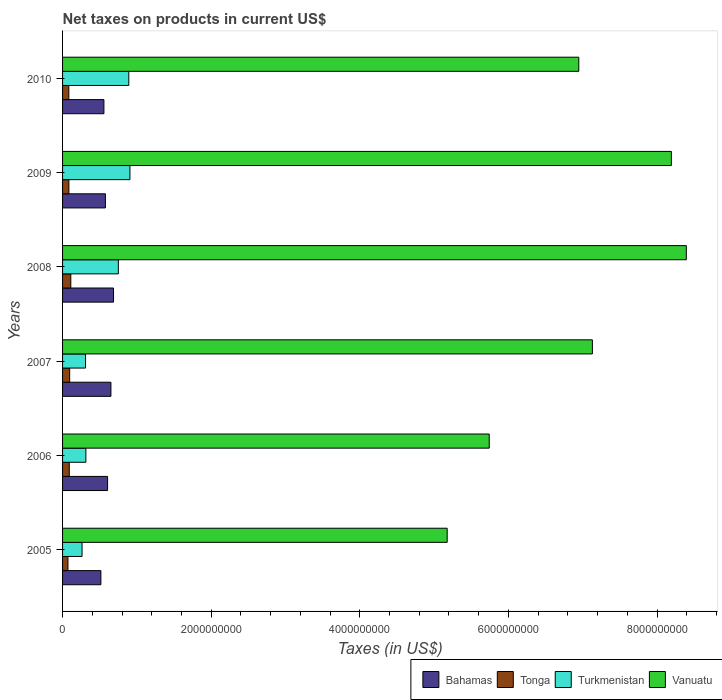How many groups of bars are there?
Offer a terse response. 6. Are the number of bars per tick equal to the number of legend labels?
Provide a short and direct response. Yes. How many bars are there on the 3rd tick from the top?
Give a very brief answer. 4. How many bars are there on the 4th tick from the bottom?
Make the answer very short. 4. What is the label of the 6th group of bars from the top?
Offer a very short reply. 2005. In how many cases, is the number of bars for a given year not equal to the number of legend labels?
Offer a terse response. 0. What is the net taxes on products in Bahamas in 2010?
Ensure brevity in your answer.  5.57e+08. Across all years, what is the maximum net taxes on products in Tonga?
Provide a succinct answer. 1.11e+08. Across all years, what is the minimum net taxes on products in Turkmenistan?
Keep it short and to the point. 2.62e+08. In which year was the net taxes on products in Turkmenistan maximum?
Provide a short and direct response. 2009. In which year was the net taxes on products in Bahamas minimum?
Provide a short and direct response. 2005. What is the total net taxes on products in Bahamas in the graph?
Provide a succinct answer. 3.59e+09. What is the difference between the net taxes on products in Bahamas in 2006 and that in 2008?
Offer a terse response. -7.99e+07. What is the difference between the net taxes on products in Vanuatu in 2010 and the net taxes on products in Bahamas in 2005?
Provide a succinct answer. 6.43e+09. What is the average net taxes on products in Vanuatu per year?
Give a very brief answer. 6.93e+09. In the year 2010, what is the difference between the net taxes on products in Tonga and net taxes on products in Bahamas?
Keep it short and to the point. -4.72e+08. In how many years, is the net taxes on products in Tonga greater than 800000000 US$?
Provide a succinct answer. 0. What is the ratio of the net taxes on products in Bahamas in 2005 to that in 2007?
Your answer should be compact. 0.79. Is the net taxes on products in Vanuatu in 2006 less than that in 2008?
Keep it short and to the point. Yes. Is the difference between the net taxes on products in Tonga in 2007 and 2009 greater than the difference between the net taxes on products in Bahamas in 2007 and 2009?
Keep it short and to the point. No. What is the difference between the highest and the second highest net taxes on products in Vanuatu?
Your answer should be compact. 2.01e+08. What is the difference between the highest and the lowest net taxes on products in Vanuatu?
Make the answer very short. 3.22e+09. Is it the case that in every year, the sum of the net taxes on products in Bahamas and net taxes on products in Turkmenistan is greater than the sum of net taxes on products in Tonga and net taxes on products in Vanuatu?
Your answer should be very brief. No. What does the 1st bar from the top in 2006 represents?
Ensure brevity in your answer.  Vanuatu. What does the 1st bar from the bottom in 2006 represents?
Give a very brief answer. Bahamas. Is it the case that in every year, the sum of the net taxes on products in Bahamas and net taxes on products in Turkmenistan is greater than the net taxes on products in Vanuatu?
Provide a succinct answer. No. How many bars are there?
Provide a succinct answer. 24. How many years are there in the graph?
Give a very brief answer. 6. What is the difference between two consecutive major ticks on the X-axis?
Provide a succinct answer. 2.00e+09. Are the values on the major ticks of X-axis written in scientific E-notation?
Ensure brevity in your answer.  No. Does the graph contain any zero values?
Make the answer very short. No. What is the title of the graph?
Make the answer very short. Net taxes on products in current US$. What is the label or title of the X-axis?
Ensure brevity in your answer.  Taxes (in US$). What is the Taxes (in US$) in Bahamas in 2005?
Give a very brief answer. 5.16e+08. What is the Taxes (in US$) of Tonga in 2005?
Your response must be concise. 7.23e+07. What is the Taxes (in US$) of Turkmenistan in 2005?
Give a very brief answer. 2.62e+08. What is the Taxes (in US$) in Vanuatu in 2005?
Your answer should be very brief. 5.18e+09. What is the Taxes (in US$) in Bahamas in 2006?
Keep it short and to the point. 6.06e+08. What is the Taxes (in US$) in Tonga in 2006?
Give a very brief answer. 9.02e+07. What is the Taxes (in US$) of Turkmenistan in 2006?
Keep it short and to the point. 3.14e+08. What is the Taxes (in US$) of Vanuatu in 2006?
Provide a succinct answer. 5.74e+09. What is the Taxes (in US$) in Bahamas in 2007?
Ensure brevity in your answer.  6.51e+08. What is the Taxes (in US$) in Tonga in 2007?
Make the answer very short. 9.57e+07. What is the Taxes (in US$) in Turkmenistan in 2007?
Your answer should be compact. 3.09e+08. What is the Taxes (in US$) of Vanuatu in 2007?
Offer a terse response. 7.13e+09. What is the Taxes (in US$) in Bahamas in 2008?
Your response must be concise. 6.86e+08. What is the Taxes (in US$) in Tonga in 2008?
Keep it short and to the point. 1.11e+08. What is the Taxes (in US$) in Turkmenistan in 2008?
Give a very brief answer. 7.51e+08. What is the Taxes (in US$) of Vanuatu in 2008?
Give a very brief answer. 8.39e+09. What is the Taxes (in US$) of Bahamas in 2009?
Keep it short and to the point. 5.76e+08. What is the Taxes (in US$) in Tonga in 2009?
Give a very brief answer. 8.51e+07. What is the Taxes (in US$) of Turkmenistan in 2009?
Offer a terse response. 9.07e+08. What is the Taxes (in US$) in Vanuatu in 2009?
Make the answer very short. 8.19e+09. What is the Taxes (in US$) in Bahamas in 2010?
Provide a succinct answer. 5.57e+08. What is the Taxes (in US$) in Tonga in 2010?
Give a very brief answer. 8.43e+07. What is the Taxes (in US$) in Turkmenistan in 2010?
Ensure brevity in your answer.  8.91e+08. What is the Taxes (in US$) in Vanuatu in 2010?
Give a very brief answer. 6.95e+09. Across all years, what is the maximum Taxes (in US$) in Bahamas?
Provide a succinct answer. 6.86e+08. Across all years, what is the maximum Taxes (in US$) of Tonga?
Keep it short and to the point. 1.11e+08. Across all years, what is the maximum Taxes (in US$) in Turkmenistan?
Provide a short and direct response. 9.07e+08. Across all years, what is the maximum Taxes (in US$) in Vanuatu?
Provide a succinct answer. 8.39e+09. Across all years, what is the minimum Taxes (in US$) of Bahamas?
Your answer should be compact. 5.16e+08. Across all years, what is the minimum Taxes (in US$) of Tonga?
Ensure brevity in your answer.  7.23e+07. Across all years, what is the minimum Taxes (in US$) in Turkmenistan?
Your answer should be very brief. 2.62e+08. Across all years, what is the minimum Taxes (in US$) of Vanuatu?
Give a very brief answer. 5.18e+09. What is the total Taxes (in US$) in Bahamas in the graph?
Offer a very short reply. 3.59e+09. What is the total Taxes (in US$) of Tonga in the graph?
Your answer should be very brief. 5.38e+08. What is the total Taxes (in US$) of Turkmenistan in the graph?
Provide a succinct answer. 3.43e+09. What is the total Taxes (in US$) of Vanuatu in the graph?
Your answer should be very brief. 4.16e+1. What is the difference between the Taxes (in US$) of Bahamas in 2005 and that in 2006?
Offer a terse response. -9.00e+07. What is the difference between the Taxes (in US$) of Tonga in 2005 and that in 2006?
Your answer should be very brief. -1.78e+07. What is the difference between the Taxes (in US$) in Turkmenistan in 2005 and that in 2006?
Offer a terse response. -5.12e+07. What is the difference between the Taxes (in US$) of Vanuatu in 2005 and that in 2006?
Provide a short and direct response. -5.66e+08. What is the difference between the Taxes (in US$) in Bahamas in 2005 and that in 2007?
Make the answer very short. -1.35e+08. What is the difference between the Taxes (in US$) in Tonga in 2005 and that in 2007?
Your answer should be very brief. -2.33e+07. What is the difference between the Taxes (in US$) of Turkmenistan in 2005 and that in 2007?
Give a very brief answer. -4.68e+07. What is the difference between the Taxes (in US$) of Vanuatu in 2005 and that in 2007?
Your answer should be very brief. -1.95e+09. What is the difference between the Taxes (in US$) in Bahamas in 2005 and that in 2008?
Keep it short and to the point. -1.70e+08. What is the difference between the Taxes (in US$) in Tonga in 2005 and that in 2008?
Your response must be concise. -3.85e+07. What is the difference between the Taxes (in US$) in Turkmenistan in 2005 and that in 2008?
Make the answer very short. -4.88e+08. What is the difference between the Taxes (in US$) in Vanuatu in 2005 and that in 2008?
Offer a very short reply. -3.22e+09. What is the difference between the Taxes (in US$) of Bahamas in 2005 and that in 2009?
Offer a very short reply. -6.07e+07. What is the difference between the Taxes (in US$) of Tonga in 2005 and that in 2009?
Provide a short and direct response. -1.27e+07. What is the difference between the Taxes (in US$) in Turkmenistan in 2005 and that in 2009?
Keep it short and to the point. -6.44e+08. What is the difference between the Taxes (in US$) of Vanuatu in 2005 and that in 2009?
Your answer should be very brief. -3.02e+09. What is the difference between the Taxes (in US$) in Bahamas in 2005 and that in 2010?
Give a very brief answer. -4.07e+07. What is the difference between the Taxes (in US$) in Tonga in 2005 and that in 2010?
Your response must be concise. -1.20e+07. What is the difference between the Taxes (in US$) of Turkmenistan in 2005 and that in 2010?
Offer a terse response. -6.29e+08. What is the difference between the Taxes (in US$) of Vanuatu in 2005 and that in 2010?
Ensure brevity in your answer.  -1.77e+09. What is the difference between the Taxes (in US$) of Bahamas in 2006 and that in 2007?
Provide a succinct answer. -4.49e+07. What is the difference between the Taxes (in US$) of Tonga in 2006 and that in 2007?
Offer a very short reply. -5.49e+06. What is the difference between the Taxes (in US$) of Turkmenistan in 2006 and that in 2007?
Your response must be concise. 4.40e+06. What is the difference between the Taxes (in US$) in Vanuatu in 2006 and that in 2007?
Your response must be concise. -1.39e+09. What is the difference between the Taxes (in US$) in Bahamas in 2006 and that in 2008?
Your answer should be compact. -7.99e+07. What is the difference between the Taxes (in US$) of Tonga in 2006 and that in 2008?
Offer a very short reply. -2.07e+07. What is the difference between the Taxes (in US$) of Turkmenistan in 2006 and that in 2008?
Provide a succinct answer. -4.37e+08. What is the difference between the Taxes (in US$) of Vanuatu in 2006 and that in 2008?
Offer a terse response. -2.65e+09. What is the difference between the Taxes (in US$) of Bahamas in 2006 and that in 2009?
Give a very brief answer. 2.93e+07. What is the difference between the Taxes (in US$) of Tonga in 2006 and that in 2009?
Offer a very short reply. 5.11e+06. What is the difference between the Taxes (in US$) in Turkmenistan in 2006 and that in 2009?
Offer a terse response. -5.93e+08. What is the difference between the Taxes (in US$) in Vanuatu in 2006 and that in 2009?
Your answer should be very brief. -2.45e+09. What is the difference between the Taxes (in US$) in Bahamas in 2006 and that in 2010?
Your response must be concise. 4.92e+07. What is the difference between the Taxes (in US$) in Tonga in 2006 and that in 2010?
Provide a short and direct response. 5.81e+06. What is the difference between the Taxes (in US$) in Turkmenistan in 2006 and that in 2010?
Keep it short and to the point. -5.78e+08. What is the difference between the Taxes (in US$) in Vanuatu in 2006 and that in 2010?
Make the answer very short. -1.20e+09. What is the difference between the Taxes (in US$) of Bahamas in 2007 and that in 2008?
Give a very brief answer. -3.50e+07. What is the difference between the Taxes (in US$) in Tonga in 2007 and that in 2008?
Keep it short and to the point. -1.52e+07. What is the difference between the Taxes (in US$) in Turkmenistan in 2007 and that in 2008?
Provide a succinct answer. -4.41e+08. What is the difference between the Taxes (in US$) in Vanuatu in 2007 and that in 2008?
Offer a terse response. -1.26e+09. What is the difference between the Taxes (in US$) in Bahamas in 2007 and that in 2009?
Ensure brevity in your answer.  7.42e+07. What is the difference between the Taxes (in US$) of Tonga in 2007 and that in 2009?
Offer a very short reply. 1.06e+07. What is the difference between the Taxes (in US$) of Turkmenistan in 2007 and that in 2009?
Make the answer very short. -5.98e+08. What is the difference between the Taxes (in US$) in Vanuatu in 2007 and that in 2009?
Offer a terse response. -1.06e+09. What is the difference between the Taxes (in US$) of Bahamas in 2007 and that in 2010?
Offer a terse response. 9.41e+07. What is the difference between the Taxes (in US$) of Tonga in 2007 and that in 2010?
Offer a terse response. 1.13e+07. What is the difference between the Taxes (in US$) in Turkmenistan in 2007 and that in 2010?
Your answer should be very brief. -5.82e+08. What is the difference between the Taxes (in US$) in Vanuatu in 2007 and that in 2010?
Make the answer very short. 1.83e+08. What is the difference between the Taxes (in US$) in Bahamas in 2008 and that in 2009?
Provide a short and direct response. 1.09e+08. What is the difference between the Taxes (in US$) in Tonga in 2008 and that in 2009?
Offer a terse response. 2.58e+07. What is the difference between the Taxes (in US$) of Turkmenistan in 2008 and that in 2009?
Ensure brevity in your answer.  -1.56e+08. What is the difference between the Taxes (in US$) of Vanuatu in 2008 and that in 2009?
Your answer should be very brief. 2.01e+08. What is the difference between the Taxes (in US$) of Bahamas in 2008 and that in 2010?
Keep it short and to the point. 1.29e+08. What is the difference between the Taxes (in US$) in Tonga in 2008 and that in 2010?
Keep it short and to the point. 2.65e+07. What is the difference between the Taxes (in US$) of Turkmenistan in 2008 and that in 2010?
Provide a short and direct response. -1.41e+08. What is the difference between the Taxes (in US$) in Vanuatu in 2008 and that in 2010?
Offer a terse response. 1.45e+09. What is the difference between the Taxes (in US$) of Bahamas in 2009 and that in 2010?
Your answer should be very brief. 1.99e+07. What is the difference between the Taxes (in US$) in Tonga in 2009 and that in 2010?
Provide a succinct answer. 7.02e+05. What is the difference between the Taxes (in US$) of Turkmenistan in 2009 and that in 2010?
Your answer should be compact. 1.54e+07. What is the difference between the Taxes (in US$) of Vanuatu in 2009 and that in 2010?
Offer a very short reply. 1.25e+09. What is the difference between the Taxes (in US$) in Bahamas in 2005 and the Taxes (in US$) in Tonga in 2006?
Provide a succinct answer. 4.26e+08. What is the difference between the Taxes (in US$) in Bahamas in 2005 and the Taxes (in US$) in Turkmenistan in 2006?
Provide a short and direct response. 2.02e+08. What is the difference between the Taxes (in US$) of Bahamas in 2005 and the Taxes (in US$) of Vanuatu in 2006?
Offer a very short reply. -5.23e+09. What is the difference between the Taxes (in US$) in Tonga in 2005 and the Taxes (in US$) in Turkmenistan in 2006?
Make the answer very short. -2.41e+08. What is the difference between the Taxes (in US$) of Tonga in 2005 and the Taxes (in US$) of Vanuatu in 2006?
Provide a short and direct response. -5.67e+09. What is the difference between the Taxes (in US$) of Turkmenistan in 2005 and the Taxes (in US$) of Vanuatu in 2006?
Ensure brevity in your answer.  -5.48e+09. What is the difference between the Taxes (in US$) of Bahamas in 2005 and the Taxes (in US$) of Tonga in 2007?
Offer a very short reply. 4.20e+08. What is the difference between the Taxes (in US$) of Bahamas in 2005 and the Taxes (in US$) of Turkmenistan in 2007?
Give a very brief answer. 2.07e+08. What is the difference between the Taxes (in US$) in Bahamas in 2005 and the Taxes (in US$) in Vanuatu in 2007?
Your answer should be compact. -6.61e+09. What is the difference between the Taxes (in US$) of Tonga in 2005 and the Taxes (in US$) of Turkmenistan in 2007?
Provide a succinct answer. -2.37e+08. What is the difference between the Taxes (in US$) in Tonga in 2005 and the Taxes (in US$) in Vanuatu in 2007?
Give a very brief answer. -7.06e+09. What is the difference between the Taxes (in US$) in Turkmenistan in 2005 and the Taxes (in US$) in Vanuatu in 2007?
Your response must be concise. -6.87e+09. What is the difference between the Taxes (in US$) in Bahamas in 2005 and the Taxes (in US$) in Tonga in 2008?
Provide a short and direct response. 4.05e+08. What is the difference between the Taxes (in US$) in Bahamas in 2005 and the Taxes (in US$) in Turkmenistan in 2008?
Your answer should be very brief. -2.35e+08. What is the difference between the Taxes (in US$) in Bahamas in 2005 and the Taxes (in US$) in Vanuatu in 2008?
Offer a terse response. -7.88e+09. What is the difference between the Taxes (in US$) of Tonga in 2005 and the Taxes (in US$) of Turkmenistan in 2008?
Keep it short and to the point. -6.78e+08. What is the difference between the Taxes (in US$) in Tonga in 2005 and the Taxes (in US$) in Vanuatu in 2008?
Your answer should be compact. -8.32e+09. What is the difference between the Taxes (in US$) in Turkmenistan in 2005 and the Taxes (in US$) in Vanuatu in 2008?
Your response must be concise. -8.13e+09. What is the difference between the Taxes (in US$) of Bahamas in 2005 and the Taxes (in US$) of Tonga in 2009?
Your answer should be very brief. 4.31e+08. What is the difference between the Taxes (in US$) in Bahamas in 2005 and the Taxes (in US$) in Turkmenistan in 2009?
Your answer should be compact. -3.91e+08. What is the difference between the Taxes (in US$) in Bahamas in 2005 and the Taxes (in US$) in Vanuatu in 2009?
Make the answer very short. -7.68e+09. What is the difference between the Taxes (in US$) of Tonga in 2005 and the Taxes (in US$) of Turkmenistan in 2009?
Your answer should be very brief. -8.34e+08. What is the difference between the Taxes (in US$) in Tonga in 2005 and the Taxes (in US$) in Vanuatu in 2009?
Offer a very short reply. -8.12e+09. What is the difference between the Taxes (in US$) in Turkmenistan in 2005 and the Taxes (in US$) in Vanuatu in 2009?
Give a very brief answer. -7.93e+09. What is the difference between the Taxes (in US$) in Bahamas in 2005 and the Taxes (in US$) in Tonga in 2010?
Offer a very short reply. 4.31e+08. What is the difference between the Taxes (in US$) in Bahamas in 2005 and the Taxes (in US$) in Turkmenistan in 2010?
Your answer should be compact. -3.75e+08. What is the difference between the Taxes (in US$) of Bahamas in 2005 and the Taxes (in US$) of Vanuatu in 2010?
Give a very brief answer. -6.43e+09. What is the difference between the Taxes (in US$) in Tonga in 2005 and the Taxes (in US$) in Turkmenistan in 2010?
Offer a very short reply. -8.19e+08. What is the difference between the Taxes (in US$) in Tonga in 2005 and the Taxes (in US$) in Vanuatu in 2010?
Make the answer very short. -6.87e+09. What is the difference between the Taxes (in US$) of Turkmenistan in 2005 and the Taxes (in US$) of Vanuatu in 2010?
Your answer should be very brief. -6.68e+09. What is the difference between the Taxes (in US$) in Bahamas in 2006 and the Taxes (in US$) in Tonga in 2007?
Offer a terse response. 5.10e+08. What is the difference between the Taxes (in US$) in Bahamas in 2006 and the Taxes (in US$) in Turkmenistan in 2007?
Offer a terse response. 2.97e+08. What is the difference between the Taxes (in US$) of Bahamas in 2006 and the Taxes (in US$) of Vanuatu in 2007?
Keep it short and to the point. -6.52e+09. What is the difference between the Taxes (in US$) of Tonga in 2006 and the Taxes (in US$) of Turkmenistan in 2007?
Your answer should be very brief. -2.19e+08. What is the difference between the Taxes (in US$) in Tonga in 2006 and the Taxes (in US$) in Vanuatu in 2007?
Your answer should be very brief. -7.04e+09. What is the difference between the Taxes (in US$) in Turkmenistan in 2006 and the Taxes (in US$) in Vanuatu in 2007?
Your answer should be compact. -6.82e+09. What is the difference between the Taxes (in US$) of Bahamas in 2006 and the Taxes (in US$) of Tonga in 2008?
Provide a succinct answer. 4.95e+08. What is the difference between the Taxes (in US$) in Bahamas in 2006 and the Taxes (in US$) in Turkmenistan in 2008?
Give a very brief answer. -1.45e+08. What is the difference between the Taxes (in US$) in Bahamas in 2006 and the Taxes (in US$) in Vanuatu in 2008?
Provide a short and direct response. -7.79e+09. What is the difference between the Taxes (in US$) of Tonga in 2006 and the Taxes (in US$) of Turkmenistan in 2008?
Keep it short and to the point. -6.60e+08. What is the difference between the Taxes (in US$) of Tonga in 2006 and the Taxes (in US$) of Vanuatu in 2008?
Offer a terse response. -8.30e+09. What is the difference between the Taxes (in US$) in Turkmenistan in 2006 and the Taxes (in US$) in Vanuatu in 2008?
Keep it short and to the point. -8.08e+09. What is the difference between the Taxes (in US$) of Bahamas in 2006 and the Taxes (in US$) of Tonga in 2009?
Keep it short and to the point. 5.21e+08. What is the difference between the Taxes (in US$) of Bahamas in 2006 and the Taxes (in US$) of Turkmenistan in 2009?
Offer a very short reply. -3.01e+08. What is the difference between the Taxes (in US$) of Bahamas in 2006 and the Taxes (in US$) of Vanuatu in 2009?
Ensure brevity in your answer.  -7.59e+09. What is the difference between the Taxes (in US$) in Tonga in 2006 and the Taxes (in US$) in Turkmenistan in 2009?
Your answer should be compact. -8.17e+08. What is the difference between the Taxes (in US$) in Tonga in 2006 and the Taxes (in US$) in Vanuatu in 2009?
Your answer should be very brief. -8.10e+09. What is the difference between the Taxes (in US$) of Turkmenistan in 2006 and the Taxes (in US$) of Vanuatu in 2009?
Ensure brevity in your answer.  -7.88e+09. What is the difference between the Taxes (in US$) of Bahamas in 2006 and the Taxes (in US$) of Tonga in 2010?
Your answer should be compact. 5.21e+08. What is the difference between the Taxes (in US$) of Bahamas in 2006 and the Taxes (in US$) of Turkmenistan in 2010?
Your response must be concise. -2.85e+08. What is the difference between the Taxes (in US$) in Bahamas in 2006 and the Taxes (in US$) in Vanuatu in 2010?
Keep it short and to the point. -6.34e+09. What is the difference between the Taxes (in US$) in Tonga in 2006 and the Taxes (in US$) in Turkmenistan in 2010?
Keep it short and to the point. -8.01e+08. What is the difference between the Taxes (in US$) in Tonga in 2006 and the Taxes (in US$) in Vanuatu in 2010?
Provide a succinct answer. -6.86e+09. What is the difference between the Taxes (in US$) of Turkmenistan in 2006 and the Taxes (in US$) of Vanuatu in 2010?
Ensure brevity in your answer.  -6.63e+09. What is the difference between the Taxes (in US$) of Bahamas in 2007 and the Taxes (in US$) of Tonga in 2008?
Make the answer very short. 5.40e+08. What is the difference between the Taxes (in US$) in Bahamas in 2007 and the Taxes (in US$) in Turkmenistan in 2008?
Keep it short and to the point. -1.00e+08. What is the difference between the Taxes (in US$) of Bahamas in 2007 and the Taxes (in US$) of Vanuatu in 2008?
Keep it short and to the point. -7.74e+09. What is the difference between the Taxes (in US$) in Tonga in 2007 and the Taxes (in US$) in Turkmenistan in 2008?
Offer a very short reply. -6.55e+08. What is the difference between the Taxes (in US$) in Tonga in 2007 and the Taxes (in US$) in Vanuatu in 2008?
Provide a succinct answer. -8.30e+09. What is the difference between the Taxes (in US$) in Turkmenistan in 2007 and the Taxes (in US$) in Vanuatu in 2008?
Ensure brevity in your answer.  -8.08e+09. What is the difference between the Taxes (in US$) of Bahamas in 2007 and the Taxes (in US$) of Tonga in 2009?
Provide a succinct answer. 5.66e+08. What is the difference between the Taxes (in US$) in Bahamas in 2007 and the Taxes (in US$) in Turkmenistan in 2009?
Your response must be concise. -2.56e+08. What is the difference between the Taxes (in US$) of Bahamas in 2007 and the Taxes (in US$) of Vanuatu in 2009?
Your answer should be compact. -7.54e+09. What is the difference between the Taxes (in US$) of Tonga in 2007 and the Taxes (in US$) of Turkmenistan in 2009?
Your response must be concise. -8.11e+08. What is the difference between the Taxes (in US$) in Tonga in 2007 and the Taxes (in US$) in Vanuatu in 2009?
Make the answer very short. -8.10e+09. What is the difference between the Taxes (in US$) in Turkmenistan in 2007 and the Taxes (in US$) in Vanuatu in 2009?
Provide a succinct answer. -7.88e+09. What is the difference between the Taxes (in US$) in Bahamas in 2007 and the Taxes (in US$) in Tonga in 2010?
Keep it short and to the point. 5.66e+08. What is the difference between the Taxes (in US$) of Bahamas in 2007 and the Taxes (in US$) of Turkmenistan in 2010?
Offer a terse response. -2.41e+08. What is the difference between the Taxes (in US$) of Bahamas in 2007 and the Taxes (in US$) of Vanuatu in 2010?
Keep it short and to the point. -6.30e+09. What is the difference between the Taxes (in US$) of Tonga in 2007 and the Taxes (in US$) of Turkmenistan in 2010?
Offer a very short reply. -7.96e+08. What is the difference between the Taxes (in US$) in Tonga in 2007 and the Taxes (in US$) in Vanuatu in 2010?
Keep it short and to the point. -6.85e+09. What is the difference between the Taxes (in US$) of Turkmenistan in 2007 and the Taxes (in US$) of Vanuatu in 2010?
Provide a short and direct response. -6.64e+09. What is the difference between the Taxes (in US$) in Bahamas in 2008 and the Taxes (in US$) in Tonga in 2009?
Make the answer very short. 6.01e+08. What is the difference between the Taxes (in US$) of Bahamas in 2008 and the Taxes (in US$) of Turkmenistan in 2009?
Ensure brevity in your answer.  -2.21e+08. What is the difference between the Taxes (in US$) in Bahamas in 2008 and the Taxes (in US$) in Vanuatu in 2009?
Make the answer very short. -7.51e+09. What is the difference between the Taxes (in US$) of Tonga in 2008 and the Taxes (in US$) of Turkmenistan in 2009?
Offer a terse response. -7.96e+08. What is the difference between the Taxes (in US$) in Tonga in 2008 and the Taxes (in US$) in Vanuatu in 2009?
Offer a very short reply. -8.08e+09. What is the difference between the Taxes (in US$) of Turkmenistan in 2008 and the Taxes (in US$) of Vanuatu in 2009?
Keep it short and to the point. -7.44e+09. What is the difference between the Taxes (in US$) in Bahamas in 2008 and the Taxes (in US$) in Tonga in 2010?
Provide a short and direct response. 6.01e+08. What is the difference between the Taxes (in US$) in Bahamas in 2008 and the Taxes (in US$) in Turkmenistan in 2010?
Your answer should be very brief. -2.06e+08. What is the difference between the Taxes (in US$) in Bahamas in 2008 and the Taxes (in US$) in Vanuatu in 2010?
Ensure brevity in your answer.  -6.26e+09. What is the difference between the Taxes (in US$) of Tonga in 2008 and the Taxes (in US$) of Turkmenistan in 2010?
Your answer should be very brief. -7.80e+08. What is the difference between the Taxes (in US$) of Tonga in 2008 and the Taxes (in US$) of Vanuatu in 2010?
Provide a short and direct response. -6.84e+09. What is the difference between the Taxes (in US$) in Turkmenistan in 2008 and the Taxes (in US$) in Vanuatu in 2010?
Give a very brief answer. -6.20e+09. What is the difference between the Taxes (in US$) of Bahamas in 2009 and the Taxes (in US$) of Tonga in 2010?
Offer a terse response. 4.92e+08. What is the difference between the Taxes (in US$) of Bahamas in 2009 and the Taxes (in US$) of Turkmenistan in 2010?
Offer a very short reply. -3.15e+08. What is the difference between the Taxes (in US$) in Bahamas in 2009 and the Taxes (in US$) in Vanuatu in 2010?
Keep it short and to the point. -6.37e+09. What is the difference between the Taxes (in US$) of Tonga in 2009 and the Taxes (in US$) of Turkmenistan in 2010?
Make the answer very short. -8.06e+08. What is the difference between the Taxes (in US$) of Tonga in 2009 and the Taxes (in US$) of Vanuatu in 2010?
Offer a terse response. -6.86e+09. What is the difference between the Taxes (in US$) of Turkmenistan in 2009 and the Taxes (in US$) of Vanuatu in 2010?
Your answer should be compact. -6.04e+09. What is the average Taxes (in US$) in Bahamas per year?
Ensure brevity in your answer.  5.98e+08. What is the average Taxes (in US$) in Tonga per year?
Your response must be concise. 8.97e+07. What is the average Taxes (in US$) of Turkmenistan per year?
Make the answer very short. 5.72e+08. What is the average Taxes (in US$) of Vanuatu per year?
Ensure brevity in your answer.  6.93e+09. In the year 2005, what is the difference between the Taxes (in US$) of Bahamas and Taxes (in US$) of Tonga?
Your response must be concise. 4.43e+08. In the year 2005, what is the difference between the Taxes (in US$) of Bahamas and Taxes (in US$) of Turkmenistan?
Your response must be concise. 2.53e+08. In the year 2005, what is the difference between the Taxes (in US$) in Bahamas and Taxes (in US$) in Vanuatu?
Offer a terse response. -4.66e+09. In the year 2005, what is the difference between the Taxes (in US$) in Tonga and Taxes (in US$) in Turkmenistan?
Your response must be concise. -1.90e+08. In the year 2005, what is the difference between the Taxes (in US$) of Tonga and Taxes (in US$) of Vanuatu?
Your answer should be very brief. -5.10e+09. In the year 2005, what is the difference between the Taxes (in US$) in Turkmenistan and Taxes (in US$) in Vanuatu?
Your answer should be very brief. -4.91e+09. In the year 2006, what is the difference between the Taxes (in US$) of Bahamas and Taxes (in US$) of Tonga?
Offer a very short reply. 5.16e+08. In the year 2006, what is the difference between the Taxes (in US$) in Bahamas and Taxes (in US$) in Turkmenistan?
Provide a succinct answer. 2.92e+08. In the year 2006, what is the difference between the Taxes (in US$) of Bahamas and Taxes (in US$) of Vanuatu?
Provide a succinct answer. -5.14e+09. In the year 2006, what is the difference between the Taxes (in US$) of Tonga and Taxes (in US$) of Turkmenistan?
Provide a short and direct response. -2.23e+08. In the year 2006, what is the difference between the Taxes (in US$) of Tonga and Taxes (in US$) of Vanuatu?
Offer a very short reply. -5.65e+09. In the year 2006, what is the difference between the Taxes (in US$) of Turkmenistan and Taxes (in US$) of Vanuatu?
Provide a succinct answer. -5.43e+09. In the year 2007, what is the difference between the Taxes (in US$) of Bahamas and Taxes (in US$) of Tonga?
Offer a very short reply. 5.55e+08. In the year 2007, what is the difference between the Taxes (in US$) of Bahamas and Taxes (in US$) of Turkmenistan?
Provide a short and direct response. 3.41e+08. In the year 2007, what is the difference between the Taxes (in US$) of Bahamas and Taxes (in US$) of Vanuatu?
Provide a succinct answer. -6.48e+09. In the year 2007, what is the difference between the Taxes (in US$) in Tonga and Taxes (in US$) in Turkmenistan?
Offer a terse response. -2.14e+08. In the year 2007, what is the difference between the Taxes (in US$) of Tonga and Taxes (in US$) of Vanuatu?
Provide a short and direct response. -7.03e+09. In the year 2007, what is the difference between the Taxes (in US$) in Turkmenistan and Taxes (in US$) in Vanuatu?
Keep it short and to the point. -6.82e+09. In the year 2008, what is the difference between the Taxes (in US$) in Bahamas and Taxes (in US$) in Tonga?
Your answer should be compact. 5.75e+08. In the year 2008, what is the difference between the Taxes (in US$) of Bahamas and Taxes (in US$) of Turkmenistan?
Make the answer very short. -6.50e+07. In the year 2008, what is the difference between the Taxes (in US$) in Bahamas and Taxes (in US$) in Vanuatu?
Your answer should be very brief. -7.71e+09. In the year 2008, what is the difference between the Taxes (in US$) of Tonga and Taxes (in US$) of Turkmenistan?
Ensure brevity in your answer.  -6.40e+08. In the year 2008, what is the difference between the Taxes (in US$) of Tonga and Taxes (in US$) of Vanuatu?
Keep it short and to the point. -8.28e+09. In the year 2008, what is the difference between the Taxes (in US$) in Turkmenistan and Taxes (in US$) in Vanuatu?
Provide a short and direct response. -7.64e+09. In the year 2009, what is the difference between the Taxes (in US$) of Bahamas and Taxes (in US$) of Tonga?
Your answer should be compact. 4.91e+08. In the year 2009, what is the difference between the Taxes (in US$) in Bahamas and Taxes (in US$) in Turkmenistan?
Provide a succinct answer. -3.30e+08. In the year 2009, what is the difference between the Taxes (in US$) in Bahamas and Taxes (in US$) in Vanuatu?
Ensure brevity in your answer.  -7.62e+09. In the year 2009, what is the difference between the Taxes (in US$) of Tonga and Taxes (in US$) of Turkmenistan?
Ensure brevity in your answer.  -8.22e+08. In the year 2009, what is the difference between the Taxes (in US$) in Tonga and Taxes (in US$) in Vanuatu?
Offer a terse response. -8.11e+09. In the year 2009, what is the difference between the Taxes (in US$) in Turkmenistan and Taxes (in US$) in Vanuatu?
Your response must be concise. -7.29e+09. In the year 2010, what is the difference between the Taxes (in US$) in Bahamas and Taxes (in US$) in Tonga?
Keep it short and to the point. 4.72e+08. In the year 2010, what is the difference between the Taxes (in US$) in Bahamas and Taxes (in US$) in Turkmenistan?
Offer a terse response. -3.35e+08. In the year 2010, what is the difference between the Taxes (in US$) in Bahamas and Taxes (in US$) in Vanuatu?
Offer a terse response. -6.39e+09. In the year 2010, what is the difference between the Taxes (in US$) in Tonga and Taxes (in US$) in Turkmenistan?
Your answer should be very brief. -8.07e+08. In the year 2010, what is the difference between the Taxes (in US$) in Tonga and Taxes (in US$) in Vanuatu?
Offer a very short reply. -6.86e+09. In the year 2010, what is the difference between the Taxes (in US$) in Turkmenistan and Taxes (in US$) in Vanuatu?
Keep it short and to the point. -6.06e+09. What is the ratio of the Taxes (in US$) in Bahamas in 2005 to that in 2006?
Offer a very short reply. 0.85. What is the ratio of the Taxes (in US$) of Tonga in 2005 to that in 2006?
Your response must be concise. 0.8. What is the ratio of the Taxes (in US$) in Turkmenistan in 2005 to that in 2006?
Make the answer very short. 0.84. What is the ratio of the Taxes (in US$) of Vanuatu in 2005 to that in 2006?
Your answer should be compact. 0.9. What is the ratio of the Taxes (in US$) of Bahamas in 2005 to that in 2007?
Ensure brevity in your answer.  0.79. What is the ratio of the Taxes (in US$) of Tonga in 2005 to that in 2007?
Keep it short and to the point. 0.76. What is the ratio of the Taxes (in US$) in Turkmenistan in 2005 to that in 2007?
Your response must be concise. 0.85. What is the ratio of the Taxes (in US$) in Vanuatu in 2005 to that in 2007?
Keep it short and to the point. 0.73. What is the ratio of the Taxes (in US$) of Bahamas in 2005 to that in 2008?
Offer a terse response. 0.75. What is the ratio of the Taxes (in US$) in Tonga in 2005 to that in 2008?
Your response must be concise. 0.65. What is the ratio of the Taxes (in US$) of Turkmenistan in 2005 to that in 2008?
Provide a short and direct response. 0.35. What is the ratio of the Taxes (in US$) in Vanuatu in 2005 to that in 2008?
Offer a very short reply. 0.62. What is the ratio of the Taxes (in US$) of Bahamas in 2005 to that in 2009?
Ensure brevity in your answer.  0.89. What is the ratio of the Taxes (in US$) in Tonga in 2005 to that in 2009?
Provide a succinct answer. 0.85. What is the ratio of the Taxes (in US$) of Turkmenistan in 2005 to that in 2009?
Offer a very short reply. 0.29. What is the ratio of the Taxes (in US$) of Vanuatu in 2005 to that in 2009?
Your response must be concise. 0.63. What is the ratio of the Taxes (in US$) in Bahamas in 2005 to that in 2010?
Offer a terse response. 0.93. What is the ratio of the Taxes (in US$) in Tonga in 2005 to that in 2010?
Your response must be concise. 0.86. What is the ratio of the Taxes (in US$) of Turkmenistan in 2005 to that in 2010?
Offer a terse response. 0.29. What is the ratio of the Taxes (in US$) in Vanuatu in 2005 to that in 2010?
Ensure brevity in your answer.  0.75. What is the ratio of the Taxes (in US$) in Bahamas in 2006 to that in 2007?
Make the answer very short. 0.93. What is the ratio of the Taxes (in US$) in Tonga in 2006 to that in 2007?
Offer a very short reply. 0.94. What is the ratio of the Taxes (in US$) in Turkmenistan in 2006 to that in 2007?
Make the answer very short. 1.01. What is the ratio of the Taxes (in US$) of Vanuatu in 2006 to that in 2007?
Your answer should be compact. 0.81. What is the ratio of the Taxes (in US$) in Bahamas in 2006 to that in 2008?
Give a very brief answer. 0.88. What is the ratio of the Taxes (in US$) in Tonga in 2006 to that in 2008?
Make the answer very short. 0.81. What is the ratio of the Taxes (in US$) in Turkmenistan in 2006 to that in 2008?
Give a very brief answer. 0.42. What is the ratio of the Taxes (in US$) of Vanuatu in 2006 to that in 2008?
Provide a succinct answer. 0.68. What is the ratio of the Taxes (in US$) in Bahamas in 2006 to that in 2009?
Your answer should be very brief. 1.05. What is the ratio of the Taxes (in US$) in Tonga in 2006 to that in 2009?
Offer a terse response. 1.06. What is the ratio of the Taxes (in US$) in Turkmenistan in 2006 to that in 2009?
Keep it short and to the point. 0.35. What is the ratio of the Taxes (in US$) in Vanuatu in 2006 to that in 2009?
Your answer should be very brief. 0.7. What is the ratio of the Taxes (in US$) of Bahamas in 2006 to that in 2010?
Your response must be concise. 1.09. What is the ratio of the Taxes (in US$) of Tonga in 2006 to that in 2010?
Provide a succinct answer. 1.07. What is the ratio of the Taxes (in US$) in Turkmenistan in 2006 to that in 2010?
Keep it short and to the point. 0.35. What is the ratio of the Taxes (in US$) in Vanuatu in 2006 to that in 2010?
Give a very brief answer. 0.83. What is the ratio of the Taxes (in US$) in Bahamas in 2007 to that in 2008?
Your answer should be very brief. 0.95. What is the ratio of the Taxes (in US$) in Tonga in 2007 to that in 2008?
Keep it short and to the point. 0.86. What is the ratio of the Taxes (in US$) in Turkmenistan in 2007 to that in 2008?
Provide a short and direct response. 0.41. What is the ratio of the Taxes (in US$) in Vanuatu in 2007 to that in 2008?
Give a very brief answer. 0.85. What is the ratio of the Taxes (in US$) in Bahamas in 2007 to that in 2009?
Your answer should be compact. 1.13. What is the ratio of the Taxes (in US$) of Tonga in 2007 to that in 2009?
Provide a succinct answer. 1.12. What is the ratio of the Taxes (in US$) of Turkmenistan in 2007 to that in 2009?
Offer a terse response. 0.34. What is the ratio of the Taxes (in US$) of Vanuatu in 2007 to that in 2009?
Provide a short and direct response. 0.87. What is the ratio of the Taxes (in US$) of Bahamas in 2007 to that in 2010?
Ensure brevity in your answer.  1.17. What is the ratio of the Taxes (in US$) of Tonga in 2007 to that in 2010?
Make the answer very short. 1.13. What is the ratio of the Taxes (in US$) of Turkmenistan in 2007 to that in 2010?
Ensure brevity in your answer.  0.35. What is the ratio of the Taxes (in US$) in Vanuatu in 2007 to that in 2010?
Ensure brevity in your answer.  1.03. What is the ratio of the Taxes (in US$) of Bahamas in 2008 to that in 2009?
Your response must be concise. 1.19. What is the ratio of the Taxes (in US$) of Tonga in 2008 to that in 2009?
Offer a terse response. 1.3. What is the ratio of the Taxes (in US$) in Turkmenistan in 2008 to that in 2009?
Your answer should be very brief. 0.83. What is the ratio of the Taxes (in US$) of Vanuatu in 2008 to that in 2009?
Keep it short and to the point. 1.02. What is the ratio of the Taxes (in US$) in Bahamas in 2008 to that in 2010?
Make the answer very short. 1.23. What is the ratio of the Taxes (in US$) in Tonga in 2008 to that in 2010?
Offer a very short reply. 1.31. What is the ratio of the Taxes (in US$) of Turkmenistan in 2008 to that in 2010?
Your answer should be very brief. 0.84. What is the ratio of the Taxes (in US$) of Vanuatu in 2008 to that in 2010?
Your answer should be very brief. 1.21. What is the ratio of the Taxes (in US$) in Bahamas in 2009 to that in 2010?
Your response must be concise. 1.04. What is the ratio of the Taxes (in US$) of Tonga in 2009 to that in 2010?
Offer a terse response. 1.01. What is the ratio of the Taxes (in US$) in Turkmenistan in 2009 to that in 2010?
Offer a very short reply. 1.02. What is the ratio of the Taxes (in US$) of Vanuatu in 2009 to that in 2010?
Make the answer very short. 1.18. What is the difference between the highest and the second highest Taxes (in US$) in Bahamas?
Offer a very short reply. 3.50e+07. What is the difference between the highest and the second highest Taxes (in US$) of Tonga?
Keep it short and to the point. 1.52e+07. What is the difference between the highest and the second highest Taxes (in US$) of Turkmenistan?
Give a very brief answer. 1.54e+07. What is the difference between the highest and the second highest Taxes (in US$) of Vanuatu?
Your answer should be very brief. 2.01e+08. What is the difference between the highest and the lowest Taxes (in US$) of Bahamas?
Your answer should be compact. 1.70e+08. What is the difference between the highest and the lowest Taxes (in US$) of Tonga?
Your answer should be very brief. 3.85e+07. What is the difference between the highest and the lowest Taxes (in US$) of Turkmenistan?
Your response must be concise. 6.44e+08. What is the difference between the highest and the lowest Taxes (in US$) of Vanuatu?
Provide a succinct answer. 3.22e+09. 